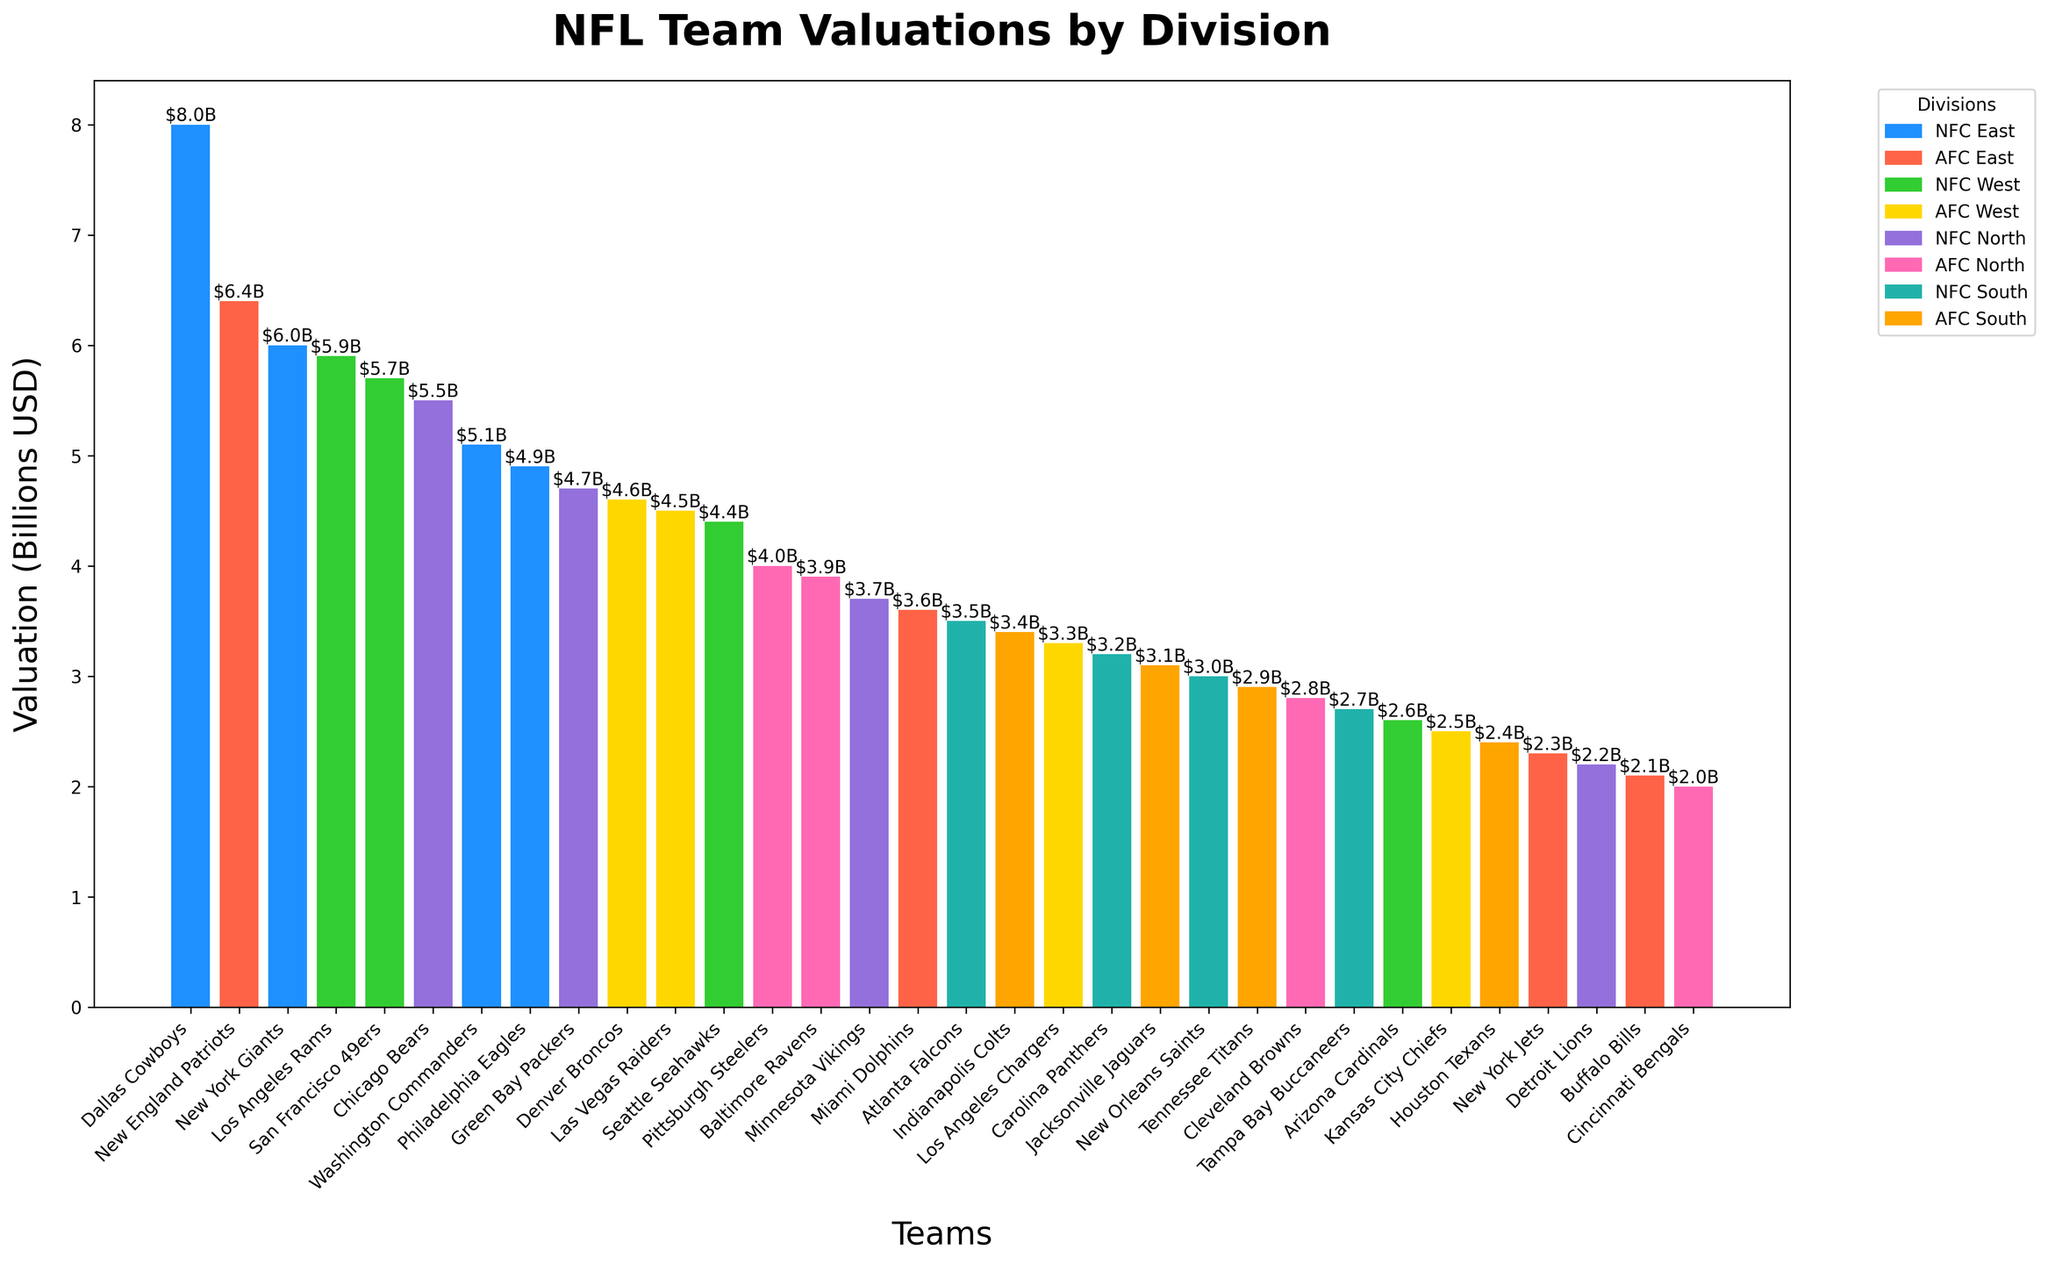Which team has the highest valuation? The chart shows the Dallas Cowboys have the tallest bar, indicating the highest valuation of $8.0 billion.
Answer: Dallas Cowboys Which division has the most teams with valuations above $5 billion? The NFC East division's bars show valuations for the Cowboys, Giants, and Commanders, three teams with valuations above $5 billion. No other division has more than two teams above $5 billion.
Answer: NFC East How many teams have valuations below $3 billion? The chart shows the heights of bars for the Titans, Browns, Buccaneers, Cardinals, Chiefs, Texans, Jets, Lions, Bills, and Bengals are under $3 billion, making a total of 10 teams.
Answer: 10 Which team in the AFC West has the highest valuation? The bars in the AFC West division show the Denver Broncos with the tallest bar at $4.6 billion.
Answer: Denver Broncos What is the difference in valuation between the New York Giants and the Philadelphia Eagles? The Giants' bar is at $6.0 billion, and the Eagles' bar is at $4.9 billion. The difference is $6.0 billion - $4.9 billion = $1.1 billion.
Answer: $1.1 billion Which has a higher total valuation: NFC North or AFC South? NFC North bars show 5.5, 4.7, 3.7, and 2.2 billion, which sum to 16.1 billion. AFC South bars show 3.4, 3.1, 2.9, and 2.4 billion, which sum to 11.8 billion. 16.1 billion is greater than 11.8 billion.
Answer: NFC North Which team in the NFC West has the lowest valuation? The bar of the Arizona Cardinals in the NFC West division is the shortest at $2.6 billion.
Answer: Arizona Cardinals What is the total valuation of the NFC South? Adding the values in the NFC South: 3.5 (Falcons) + 3.2 (Panthers) + 3.0 (Saints) + 2.7 (Buccaneers) = 12.4 billion.
Answer: $12.4 billion Comparing the AFC East and NFC West, which division has a higher average team valuation? AFC East valuations: 6.4, 3.6, 2.3, 2.1 sum to 14.4 billion. Average is 14.4/4 = 3.6 billion. NFC West valuations: 5.9, 5.7, 4.4, 2.6 sum to 18.6 billion. Average is 18.6/4 = 4.65 billion. NFC West has a higher average.
Answer: NFC West 